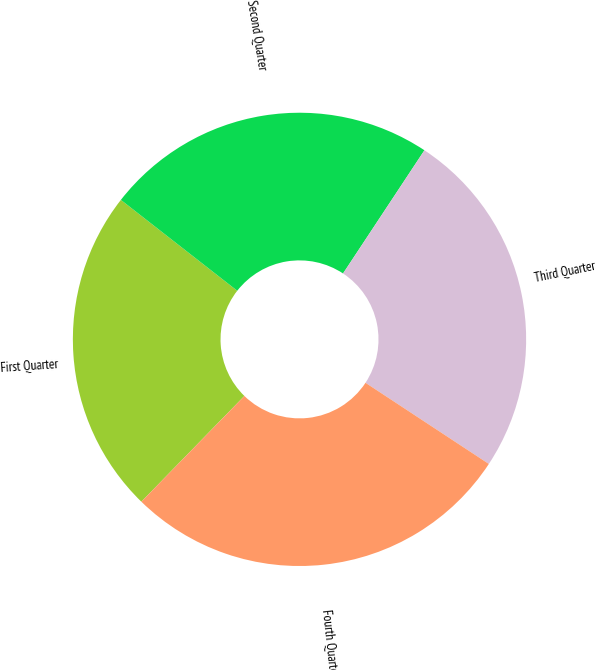Convert chart to OTSL. <chart><loc_0><loc_0><loc_500><loc_500><pie_chart><fcel>First Quarter<fcel>Second Quarter<fcel>Third Quarter<fcel>Fourth Quarter<nl><fcel>23.26%<fcel>23.74%<fcel>24.97%<fcel>28.03%<nl></chart> 